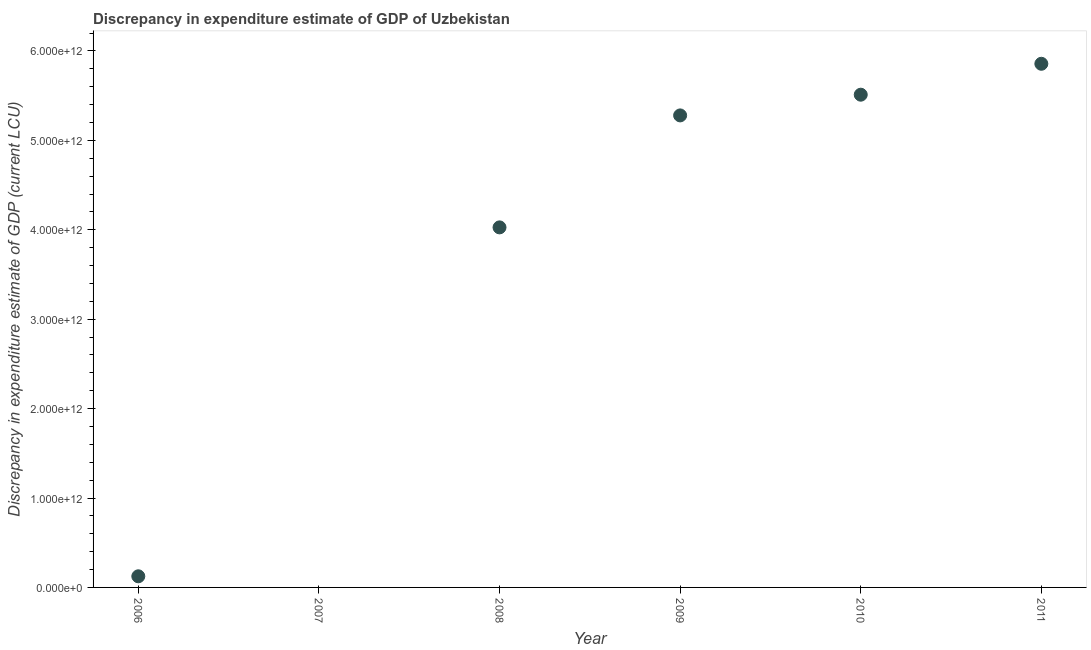What is the discrepancy in expenditure estimate of gdp in 2010?
Your answer should be compact. 5.51e+12. Across all years, what is the maximum discrepancy in expenditure estimate of gdp?
Offer a very short reply. 5.86e+12. What is the sum of the discrepancy in expenditure estimate of gdp?
Provide a short and direct response. 2.08e+13. What is the difference between the discrepancy in expenditure estimate of gdp in 2008 and 2010?
Make the answer very short. -1.48e+12. What is the average discrepancy in expenditure estimate of gdp per year?
Make the answer very short. 3.47e+12. What is the median discrepancy in expenditure estimate of gdp?
Offer a terse response. 4.65e+12. In how many years, is the discrepancy in expenditure estimate of gdp greater than 5000000000000 LCU?
Your answer should be compact. 3. What is the ratio of the discrepancy in expenditure estimate of gdp in 2008 to that in 2011?
Offer a very short reply. 0.69. Is the discrepancy in expenditure estimate of gdp in 2008 less than that in 2011?
Offer a terse response. Yes. Is the difference between the discrepancy in expenditure estimate of gdp in 2008 and 2009 greater than the difference between any two years?
Give a very brief answer. No. What is the difference between the highest and the second highest discrepancy in expenditure estimate of gdp?
Give a very brief answer. 3.46e+11. What is the difference between the highest and the lowest discrepancy in expenditure estimate of gdp?
Provide a succinct answer. 5.86e+12. In how many years, is the discrepancy in expenditure estimate of gdp greater than the average discrepancy in expenditure estimate of gdp taken over all years?
Ensure brevity in your answer.  4. What is the difference between two consecutive major ticks on the Y-axis?
Provide a short and direct response. 1.00e+12. Are the values on the major ticks of Y-axis written in scientific E-notation?
Provide a short and direct response. Yes. Does the graph contain any zero values?
Your answer should be compact. Yes. Does the graph contain grids?
Provide a succinct answer. No. What is the title of the graph?
Your answer should be very brief. Discrepancy in expenditure estimate of GDP of Uzbekistan. What is the label or title of the X-axis?
Ensure brevity in your answer.  Year. What is the label or title of the Y-axis?
Give a very brief answer. Discrepancy in expenditure estimate of GDP (current LCU). What is the Discrepancy in expenditure estimate of GDP (current LCU) in 2006?
Make the answer very short. 1.25e+11. What is the Discrepancy in expenditure estimate of GDP (current LCU) in 2007?
Make the answer very short. 0. What is the Discrepancy in expenditure estimate of GDP (current LCU) in 2008?
Offer a terse response. 4.03e+12. What is the Discrepancy in expenditure estimate of GDP (current LCU) in 2009?
Offer a very short reply. 5.28e+12. What is the Discrepancy in expenditure estimate of GDP (current LCU) in 2010?
Offer a terse response. 5.51e+12. What is the Discrepancy in expenditure estimate of GDP (current LCU) in 2011?
Offer a very short reply. 5.86e+12. What is the difference between the Discrepancy in expenditure estimate of GDP (current LCU) in 2006 and 2008?
Give a very brief answer. -3.90e+12. What is the difference between the Discrepancy in expenditure estimate of GDP (current LCU) in 2006 and 2009?
Your answer should be compact. -5.15e+12. What is the difference between the Discrepancy in expenditure estimate of GDP (current LCU) in 2006 and 2010?
Ensure brevity in your answer.  -5.39e+12. What is the difference between the Discrepancy in expenditure estimate of GDP (current LCU) in 2006 and 2011?
Give a very brief answer. -5.73e+12. What is the difference between the Discrepancy in expenditure estimate of GDP (current LCU) in 2008 and 2009?
Make the answer very short. -1.25e+12. What is the difference between the Discrepancy in expenditure estimate of GDP (current LCU) in 2008 and 2010?
Your response must be concise. -1.48e+12. What is the difference between the Discrepancy in expenditure estimate of GDP (current LCU) in 2008 and 2011?
Provide a short and direct response. -1.83e+12. What is the difference between the Discrepancy in expenditure estimate of GDP (current LCU) in 2009 and 2010?
Offer a very short reply. -2.32e+11. What is the difference between the Discrepancy in expenditure estimate of GDP (current LCU) in 2009 and 2011?
Your response must be concise. -5.77e+11. What is the difference between the Discrepancy in expenditure estimate of GDP (current LCU) in 2010 and 2011?
Offer a very short reply. -3.46e+11. What is the ratio of the Discrepancy in expenditure estimate of GDP (current LCU) in 2006 to that in 2008?
Keep it short and to the point. 0.03. What is the ratio of the Discrepancy in expenditure estimate of GDP (current LCU) in 2006 to that in 2009?
Offer a very short reply. 0.02. What is the ratio of the Discrepancy in expenditure estimate of GDP (current LCU) in 2006 to that in 2010?
Give a very brief answer. 0.02. What is the ratio of the Discrepancy in expenditure estimate of GDP (current LCU) in 2006 to that in 2011?
Provide a short and direct response. 0.02. What is the ratio of the Discrepancy in expenditure estimate of GDP (current LCU) in 2008 to that in 2009?
Keep it short and to the point. 0.76. What is the ratio of the Discrepancy in expenditure estimate of GDP (current LCU) in 2008 to that in 2010?
Your answer should be very brief. 0.73. What is the ratio of the Discrepancy in expenditure estimate of GDP (current LCU) in 2008 to that in 2011?
Make the answer very short. 0.69. What is the ratio of the Discrepancy in expenditure estimate of GDP (current LCU) in 2009 to that in 2010?
Your answer should be compact. 0.96. What is the ratio of the Discrepancy in expenditure estimate of GDP (current LCU) in 2009 to that in 2011?
Ensure brevity in your answer.  0.9. What is the ratio of the Discrepancy in expenditure estimate of GDP (current LCU) in 2010 to that in 2011?
Offer a terse response. 0.94. 